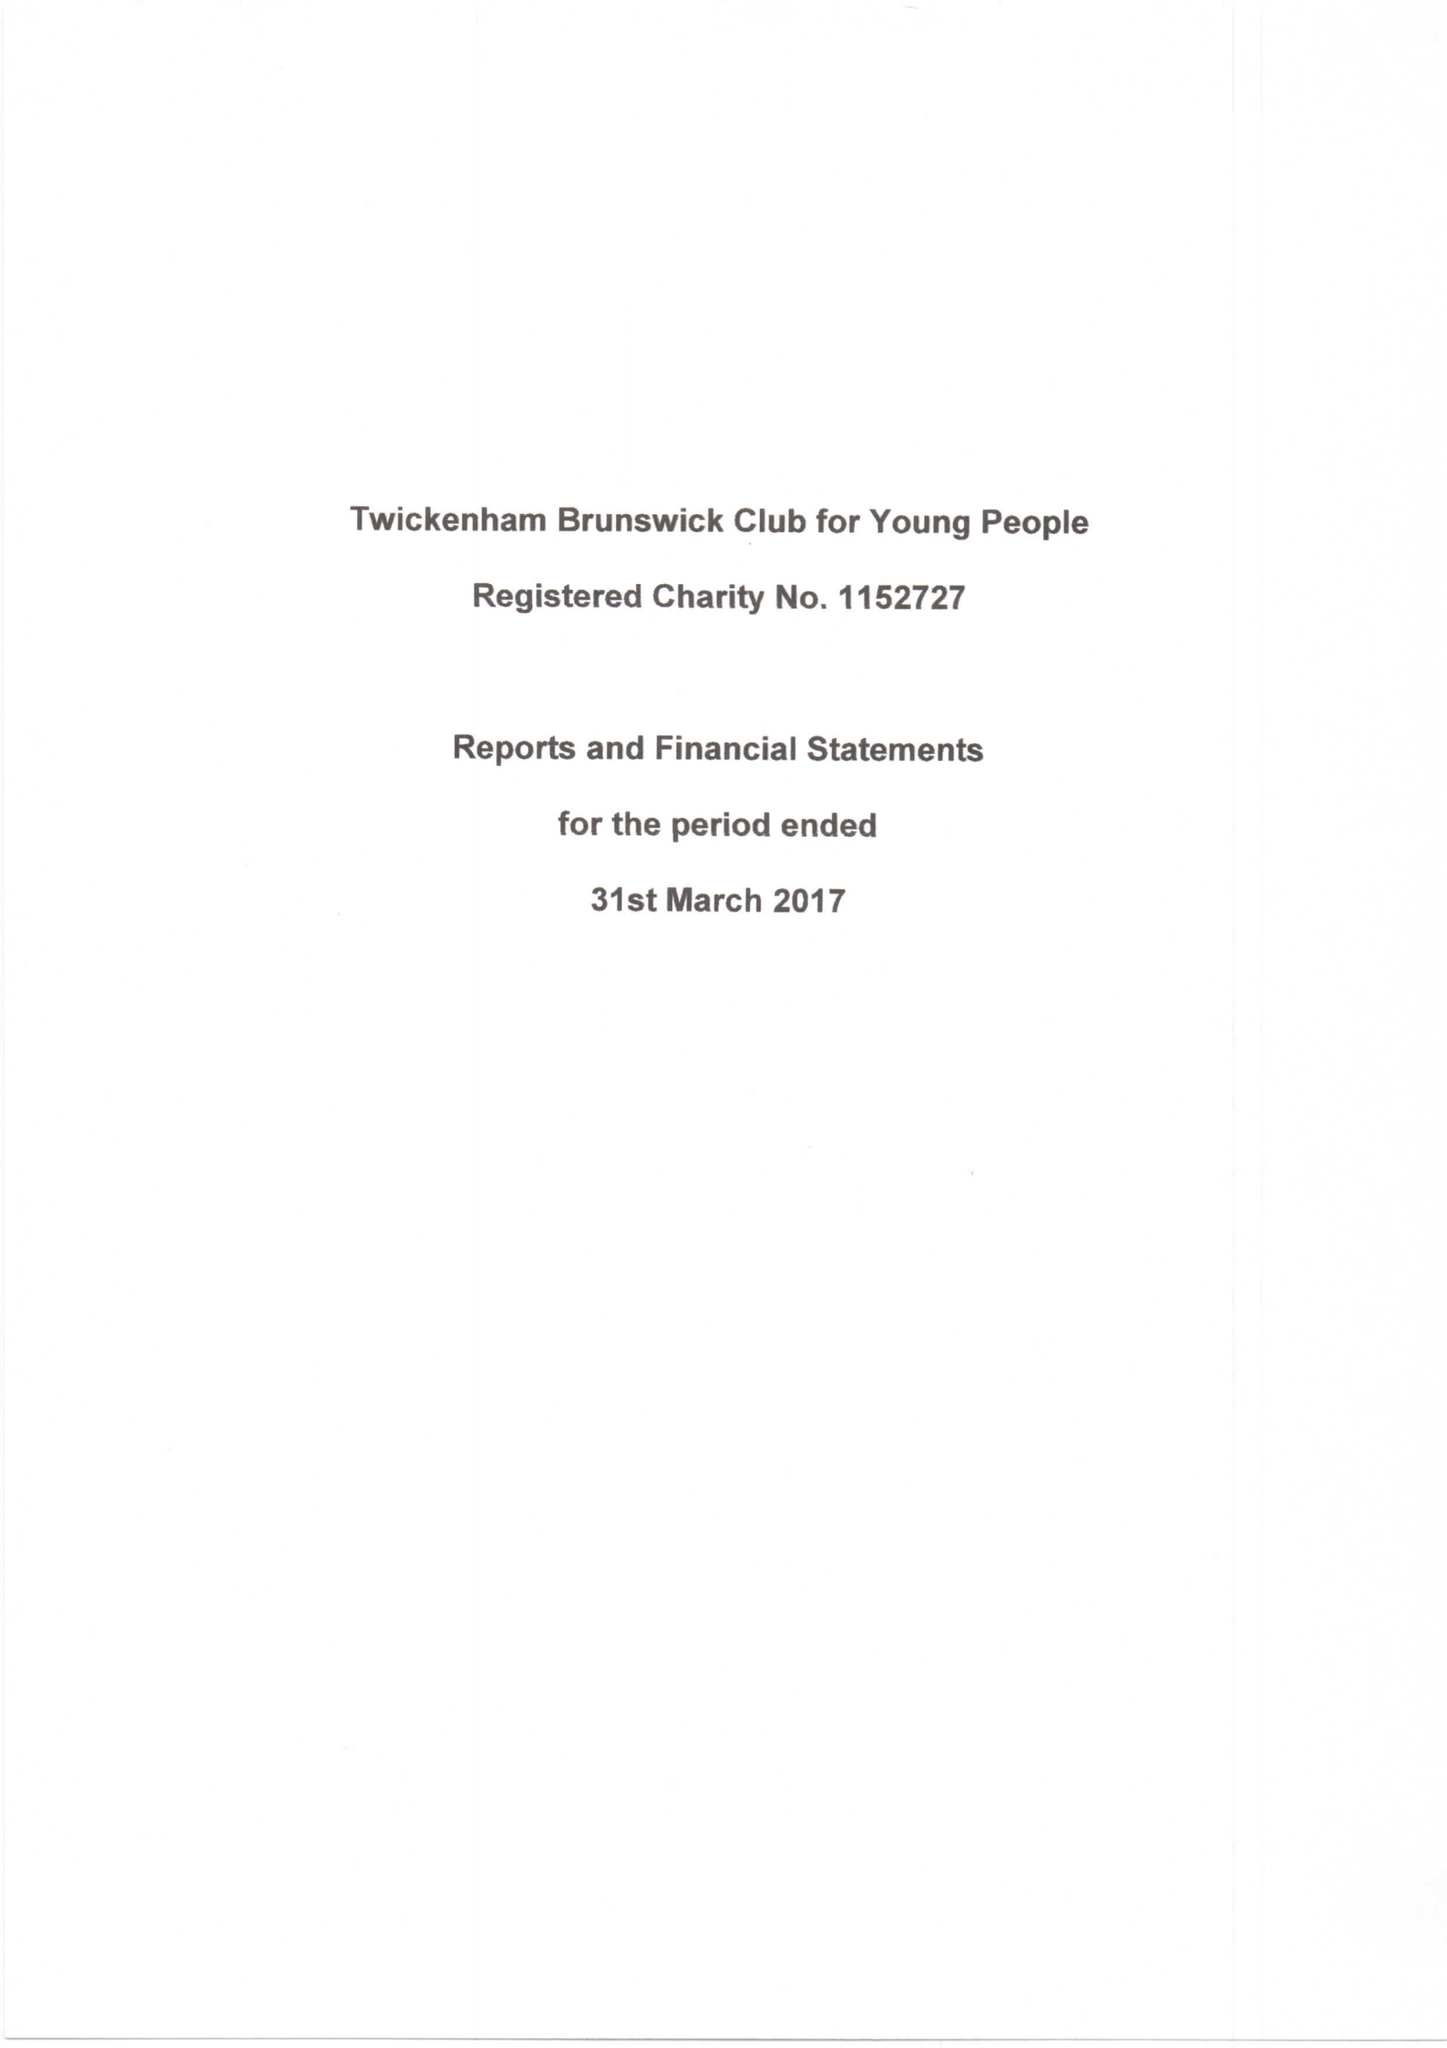What is the value for the income_annually_in_british_pounds?
Answer the question using a single word or phrase. 73611.00 